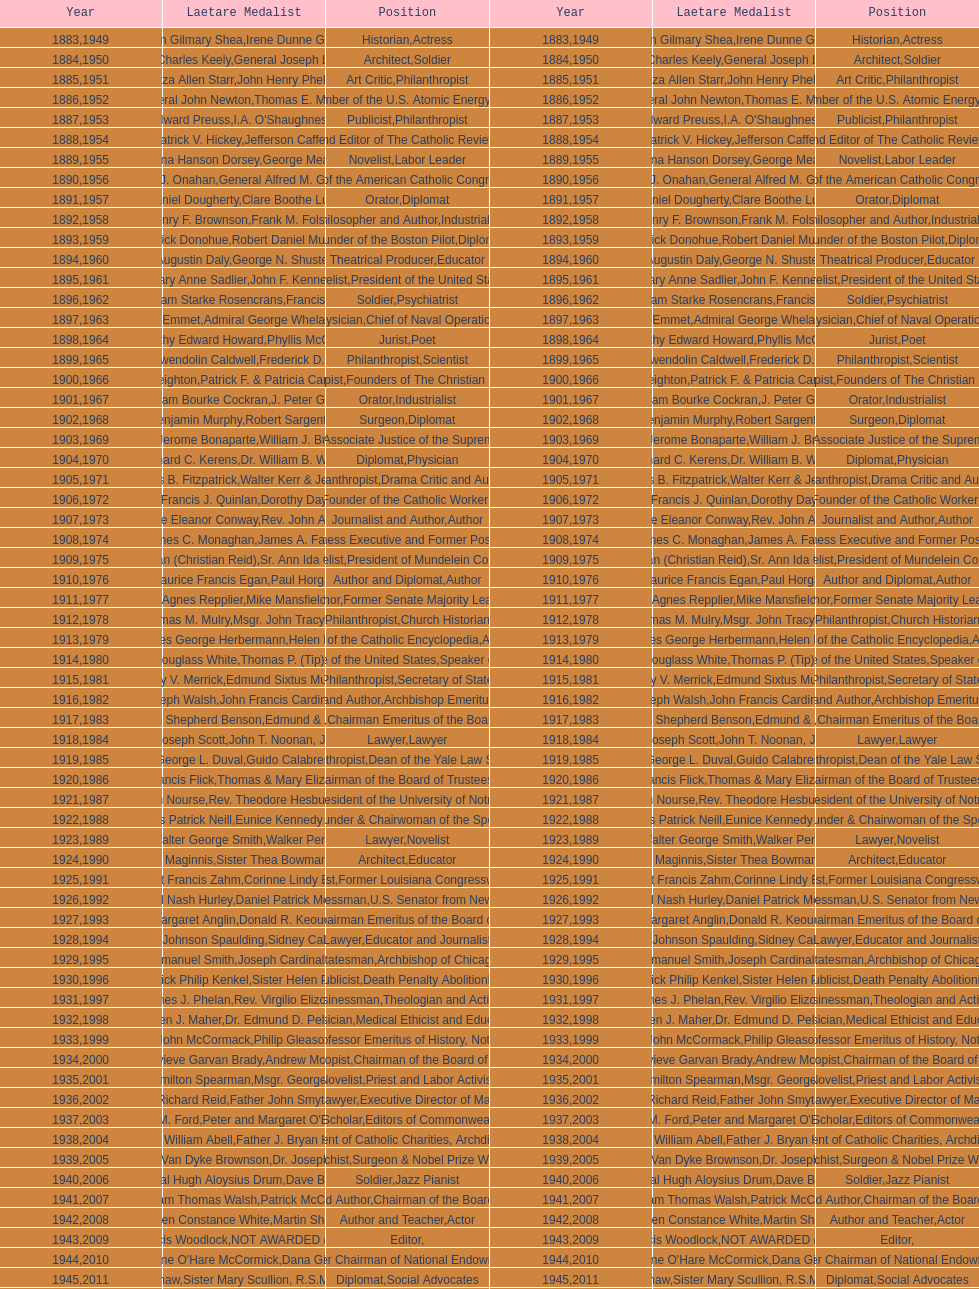Who received the medal following thomas e. murray in 1952? I.A. O'Shaughnessy. 